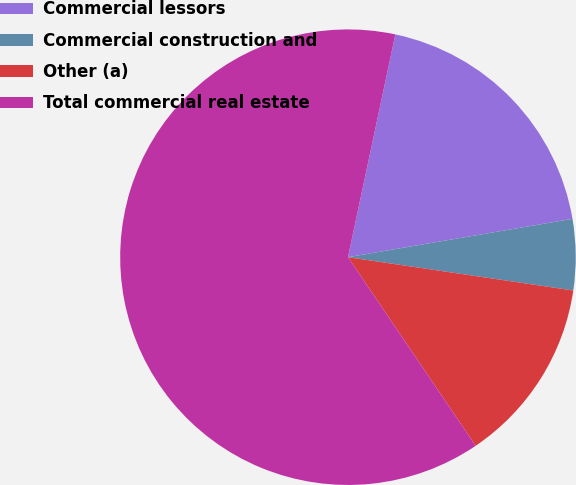Convert chart to OTSL. <chart><loc_0><loc_0><loc_500><loc_500><pie_chart><fcel>Commercial lessors<fcel>Commercial construction and<fcel>Other (a)<fcel>Total commercial real estate<nl><fcel>18.97%<fcel>5.03%<fcel>13.19%<fcel>62.81%<nl></chart> 